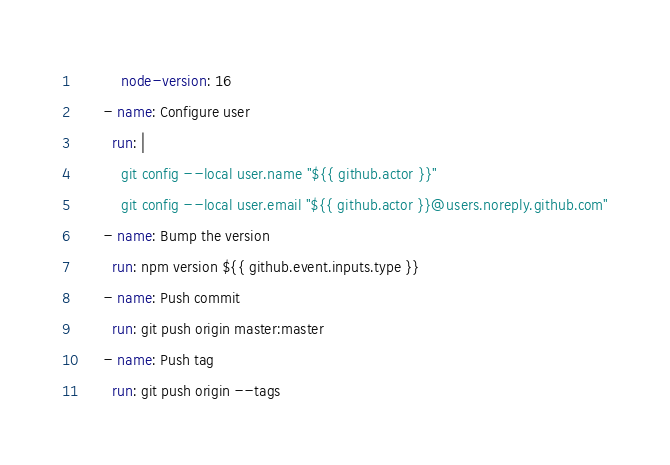Convert code to text. <code><loc_0><loc_0><loc_500><loc_500><_YAML_>          node-version: 16
      - name: Configure user
        run: |
          git config --local user.name "${{ github.actor }}"
          git config --local user.email "${{ github.actor }}@users.noreply.github.com"
      - name: Bump the version
        run: npm version ${{ github.event.inputs.type }}
      - name: Push commit
        run: git push origin master:master
      - name: Push tag
        run: git push origin --tags
</code> 